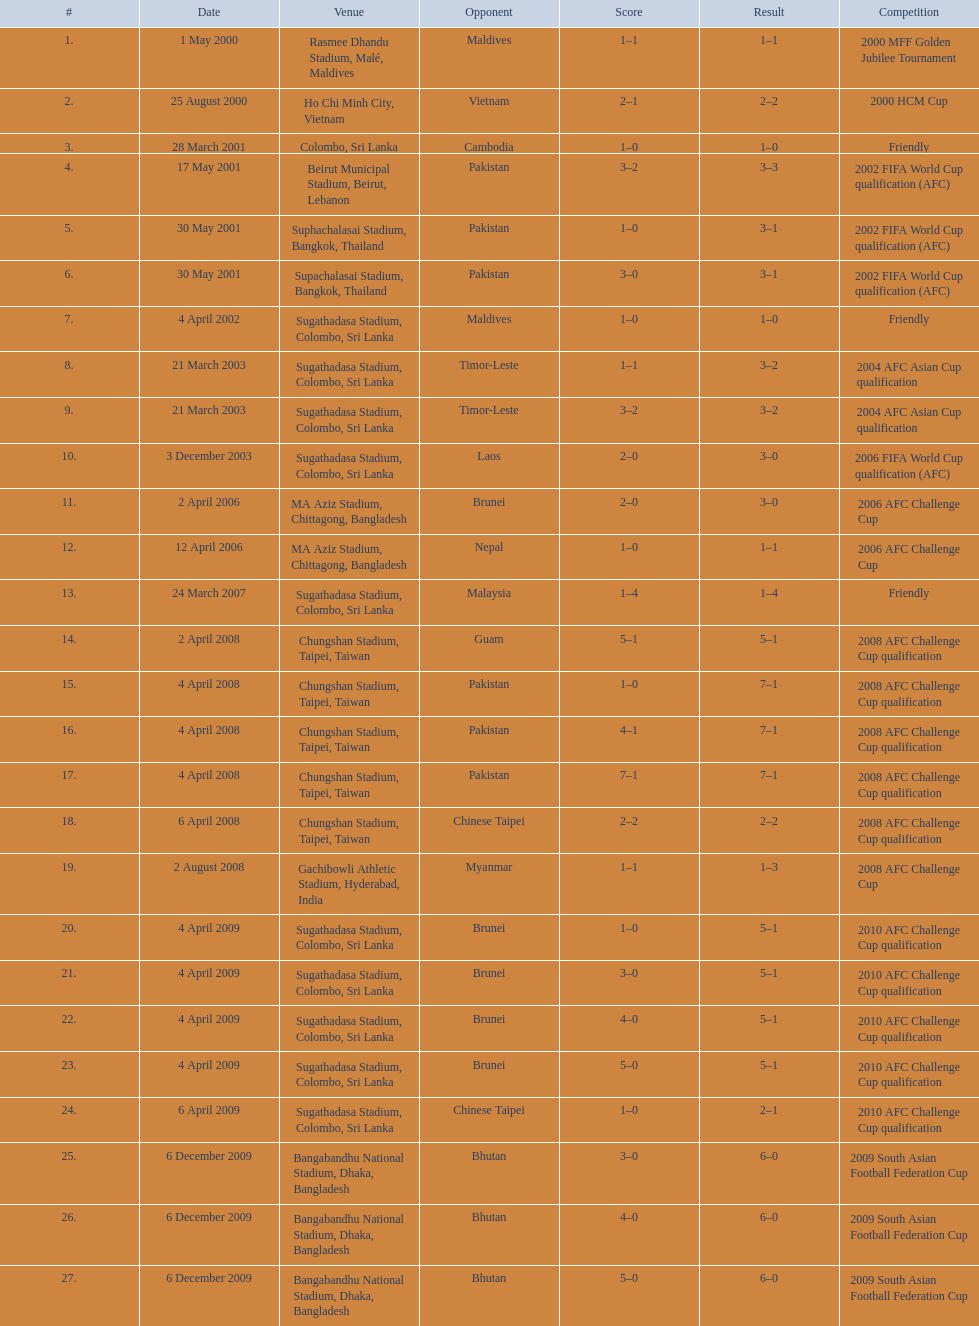Which locations are mentioned? Rasmee Dhandu Stadium, Malé, Maldives, Ho Chi Minh City, Vietnam, Colombo, Sri Lanka, Beirut Municipal Stadium, Beirut, Lebanon, Suphachalasai Stadium, Bangkok, Thailand, MA Aziz Stadium, Chittagong, Bangladesh, Sugathadasa Stadium, Colombo, Sri Lanka, Chungshan Stadium, Taipei, Taiwan, Gachibowli Athletic Stadium, Hyderabad, India, Sugathadasa Stadium, Colombo, Sri Lanka, Bangabandhu National Stadium, Dhaka, Bangladesh. Which is the highest ranked? Rasmee Dhandu Stadium, Malé, Maldives. 